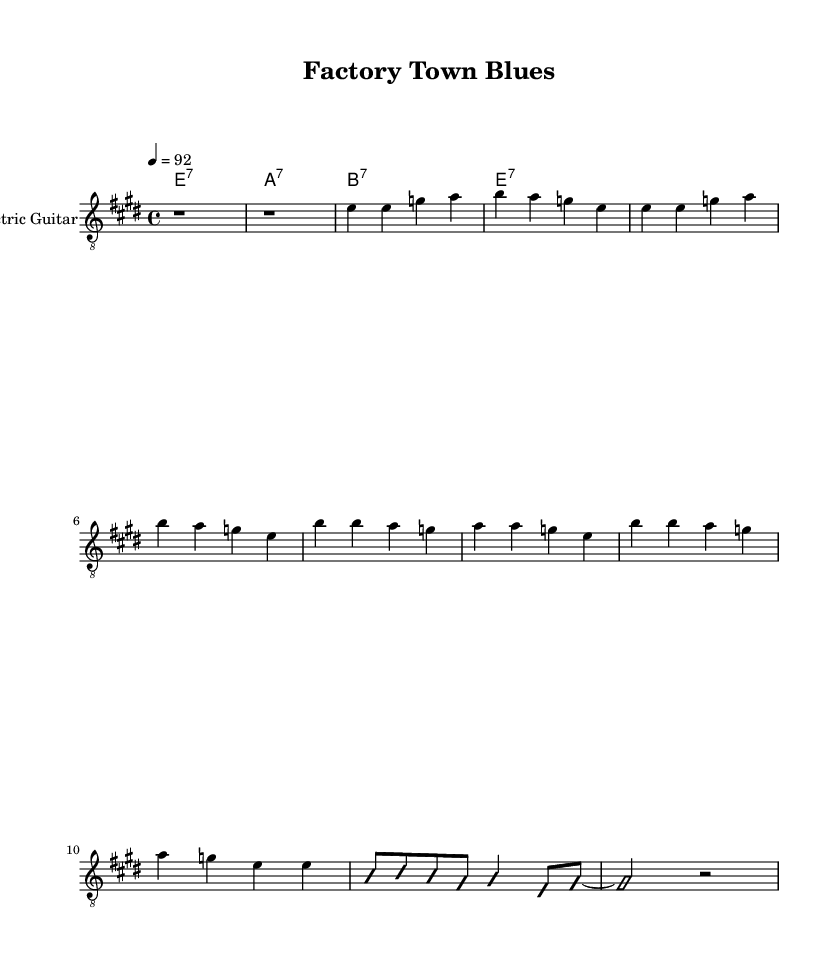What is the key signature of this music? The key signature is E major, which has four sharps (F#, C#, G#, D#).
Answer: E major What is the time signature of this piece? The time signature is 4/4, indicating that there are four beats in each measure and the quarter note receives one beat.
Answer: 4/4 What is the tempo marking for this music? The tempo marking is 92 beats per minute, indicating the speed at which the piece should be played.
Answer: 92 How many measures are in the verse? The verse consists of 4 measures, as indicated by the four sequences of notes provided.
Answer: 4 What type of chord is used in the chorus? The chorus uses dominant seventh chords, specifically E7, A7, and B7, which are characteristic of the blues genre.
Answer: Dominant seventh How does the improvised section differ from the main melody? The improvised section is more flexible and allows for personal expression, contrasting with the structured written melody.
Answer: Flexibility Why is the electric guitar chosen for this piece? The electric guitar is typical in electric blues due to its ability to produce a distinctive sound and expressive solos that convey emotional narratives.
Answer: Distinctive sound 